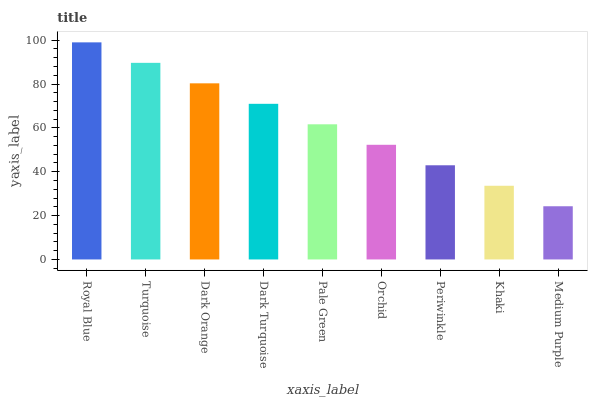Is Medium Purple the minimum?
Answer yes or no. Yes. Is Royal Blue the maximum?
Answer yes or no. Yes. Is Turquoise the minimum?
Answer yes or no. No. Is Turquoise the maximum?
Answer yes or no. No. Is Royal Blue greater than Turquoise?
Answer yes or no. Yes. Is Turquoise less than Royal Blue?
Answer yes or no. Yes. Is Turquoise greater than Royal Blue?
Answer yes or no. No. Is Royal Blue less than Turquoise?
Answer yes or no. No. Is Pale Green the high median?
Answer yes or no. Yes. Is Pale Green the low median?
Answer yes or no. Yes. Is Khaki the high median?
Answer yes or no. No. Is Dark Orange the low median?
Answer yes or no. No. 